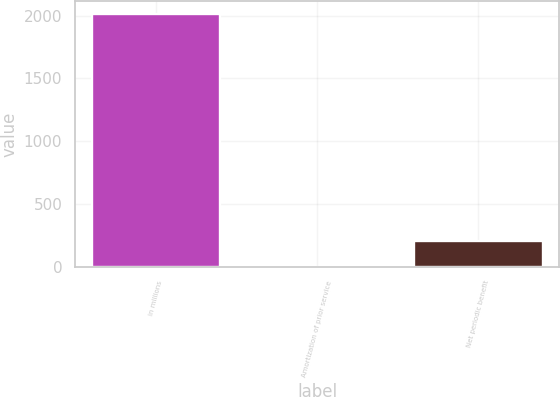Convert chart to OTSL. <chart><loc_0><loc_0><loc_500><loc_500><bar_chart><fcel>in millions<fcel>Amortization of prior service<fcel>Net periodic benefit<nl><fcel>2014<fcel>0.1<fcel>201.49<nl></chart> 